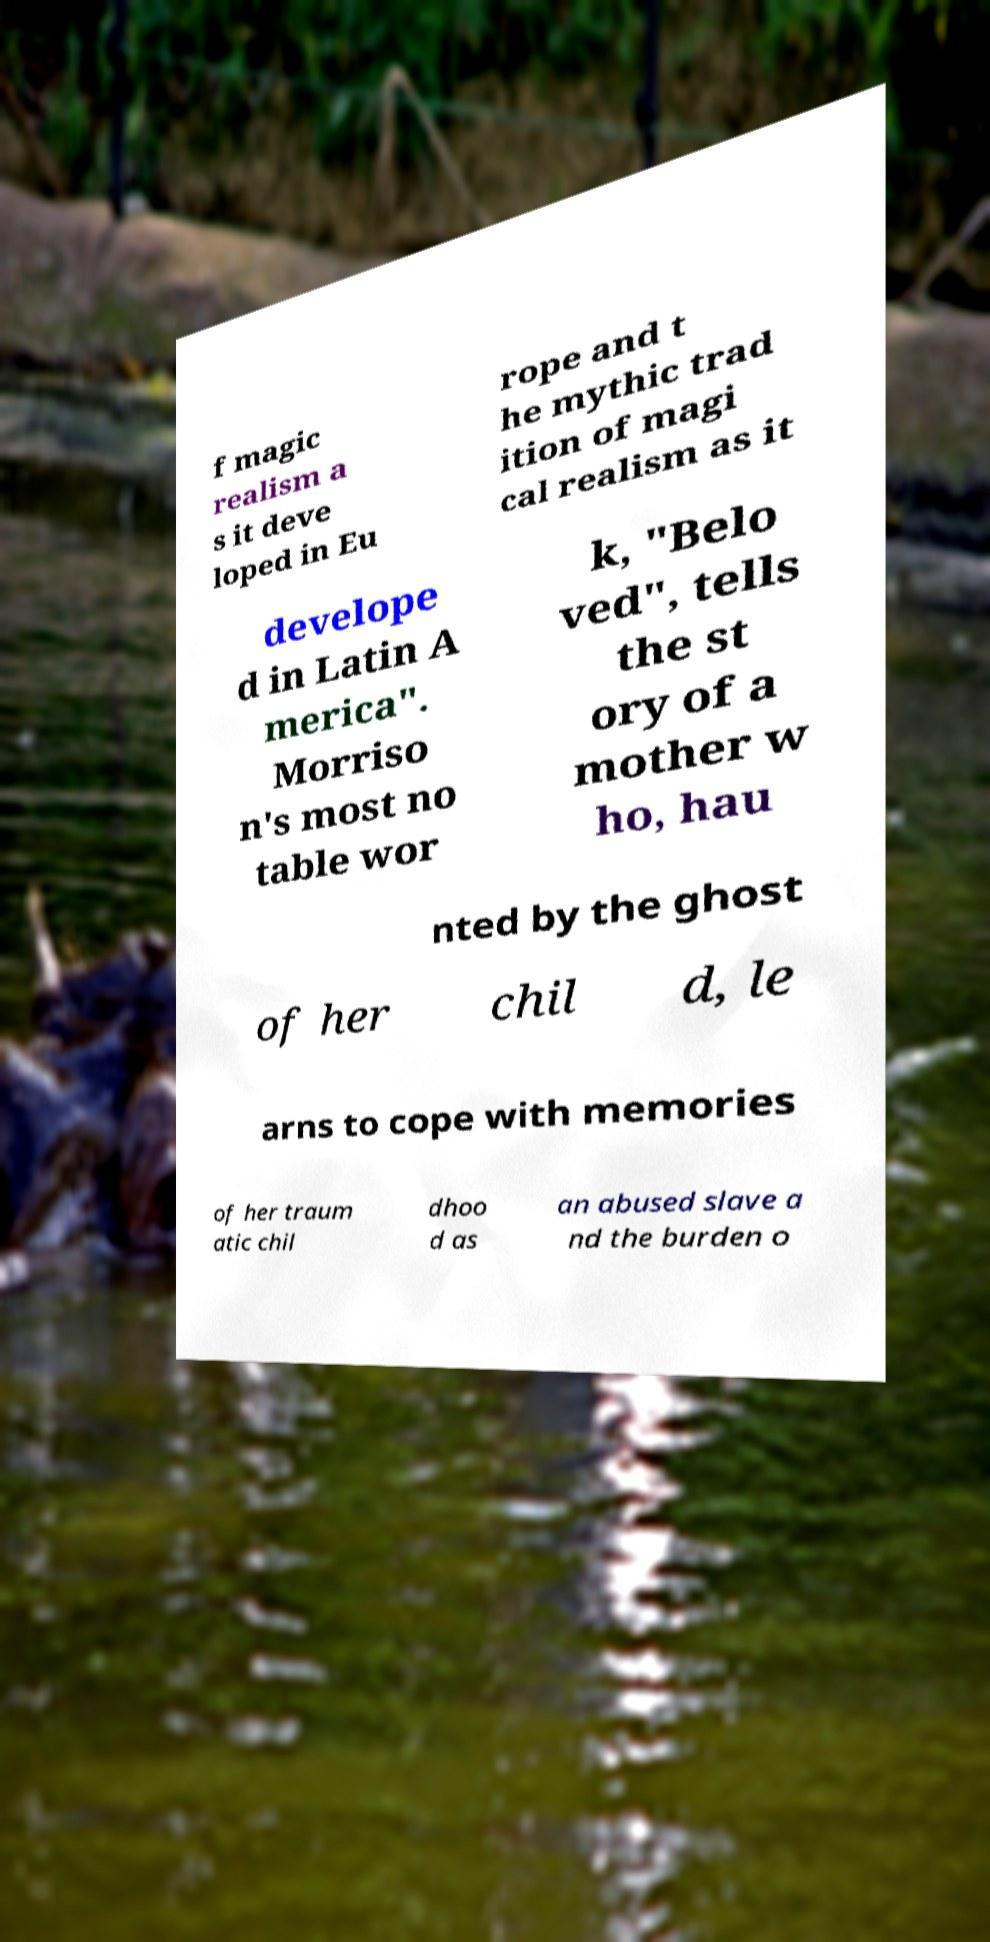There's text embedded in this image that I need extracted. Can you transcribe it verbatim? f magic realism a s it deve loped in Eu rope and t he mythic trad ition of magi cal realism as it develope d in Latin A merica". Morriso n's most no table wor k, "Belo ved", tells the st ory of a mother w ho, hau nted by the ghost of her chil d, le arns to cope with memories of her traum atic chil dhoo d as an abused slave a nd the burden o 